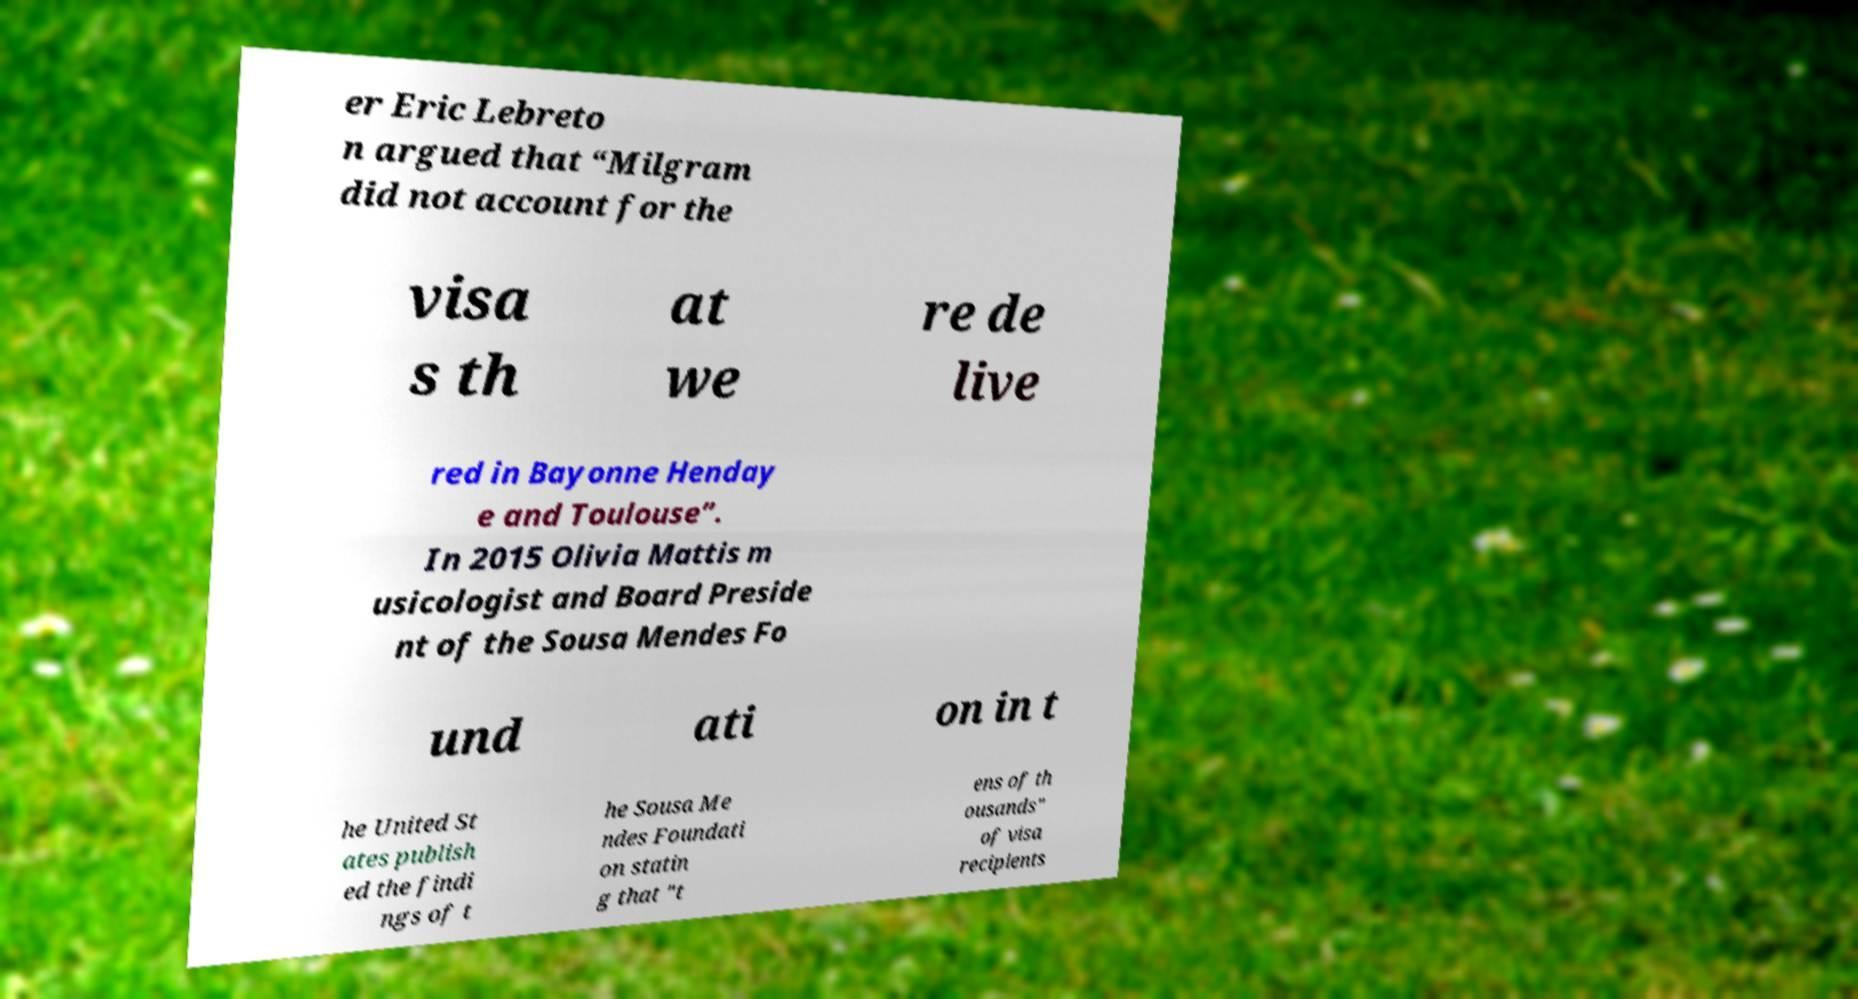Could you assist in decoding the text presented in this image and type it out clearly? er Eric Lebreto n argued that “Milgram did not account for the visa s th at we re de live red in Bayonne Henday e and Toulouse”. In 2015 Olivia Mattis m usicologist and Board Preside nt of the Sousa Mendes Fo und ati on in t he United St ates publish ed the findi ngs of t he Sousa Me ndes Foundati on statin g that "t ens of th ousands" of visa recipients 